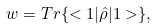Convert formula to latex. <formula><loc_0><loc_0><loc_500><loc_500>w = T r \{ < 1 | \hat { \rho } | 1 > \} ,</formula> 